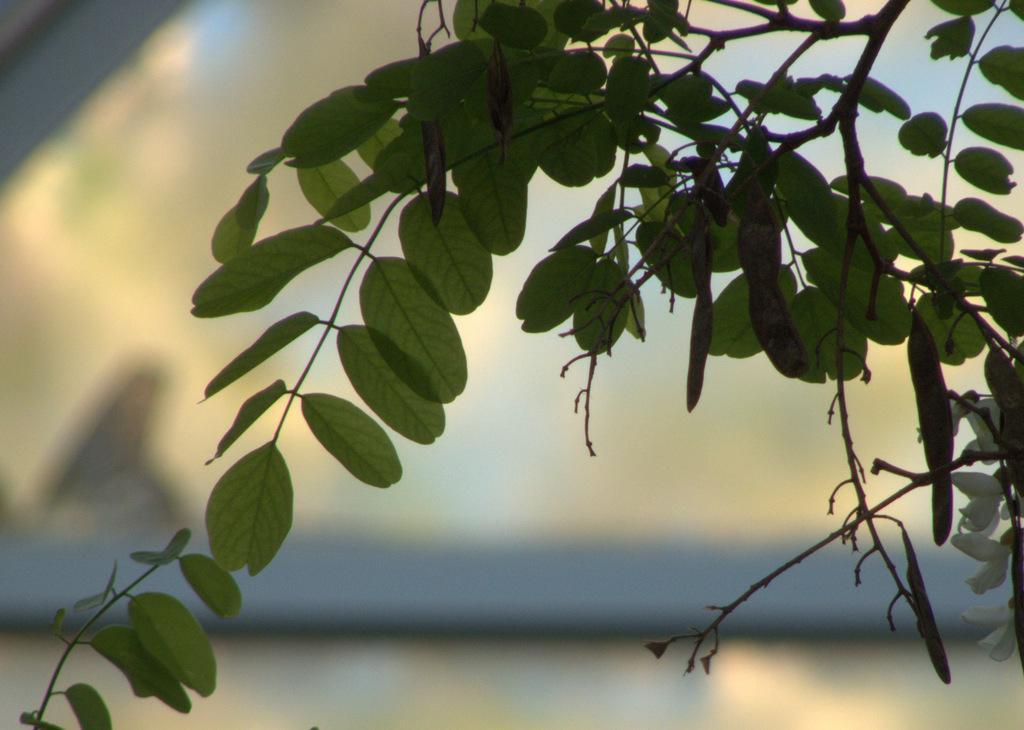Can you describe this image briefly? In this image, we can see a branch with leaves and in the background is not clear. 